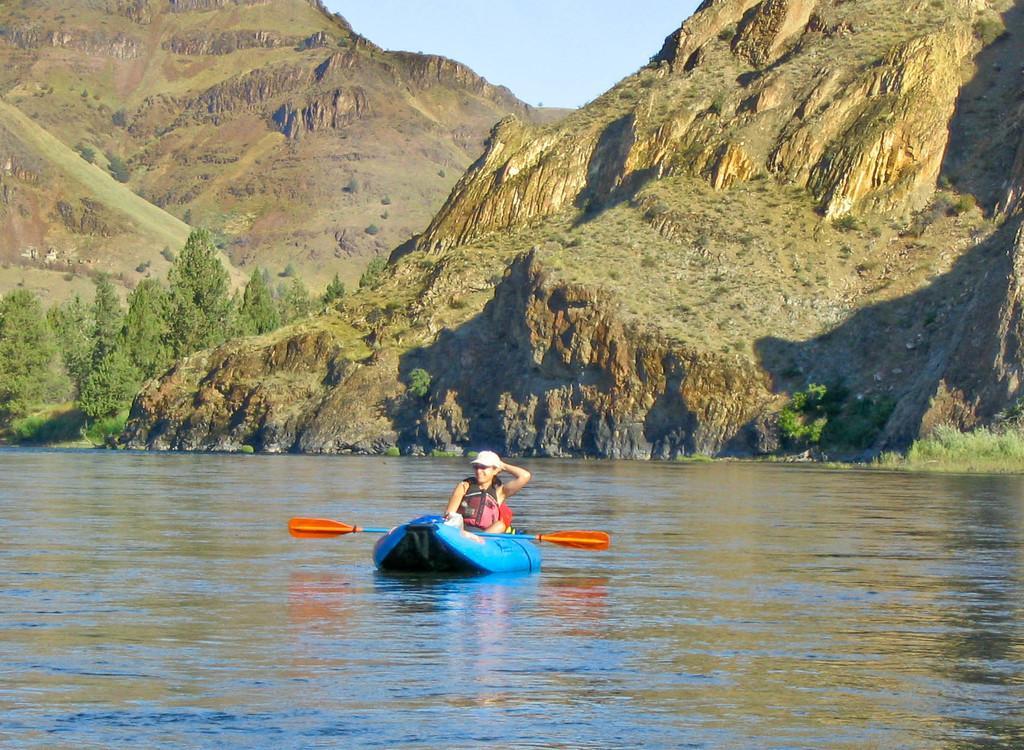How would you summarize this image in a sentence or two? In this image we can see a boat, a paddle and a woman on the surface of water. In the background, we can see mountains, trees and the sky. 